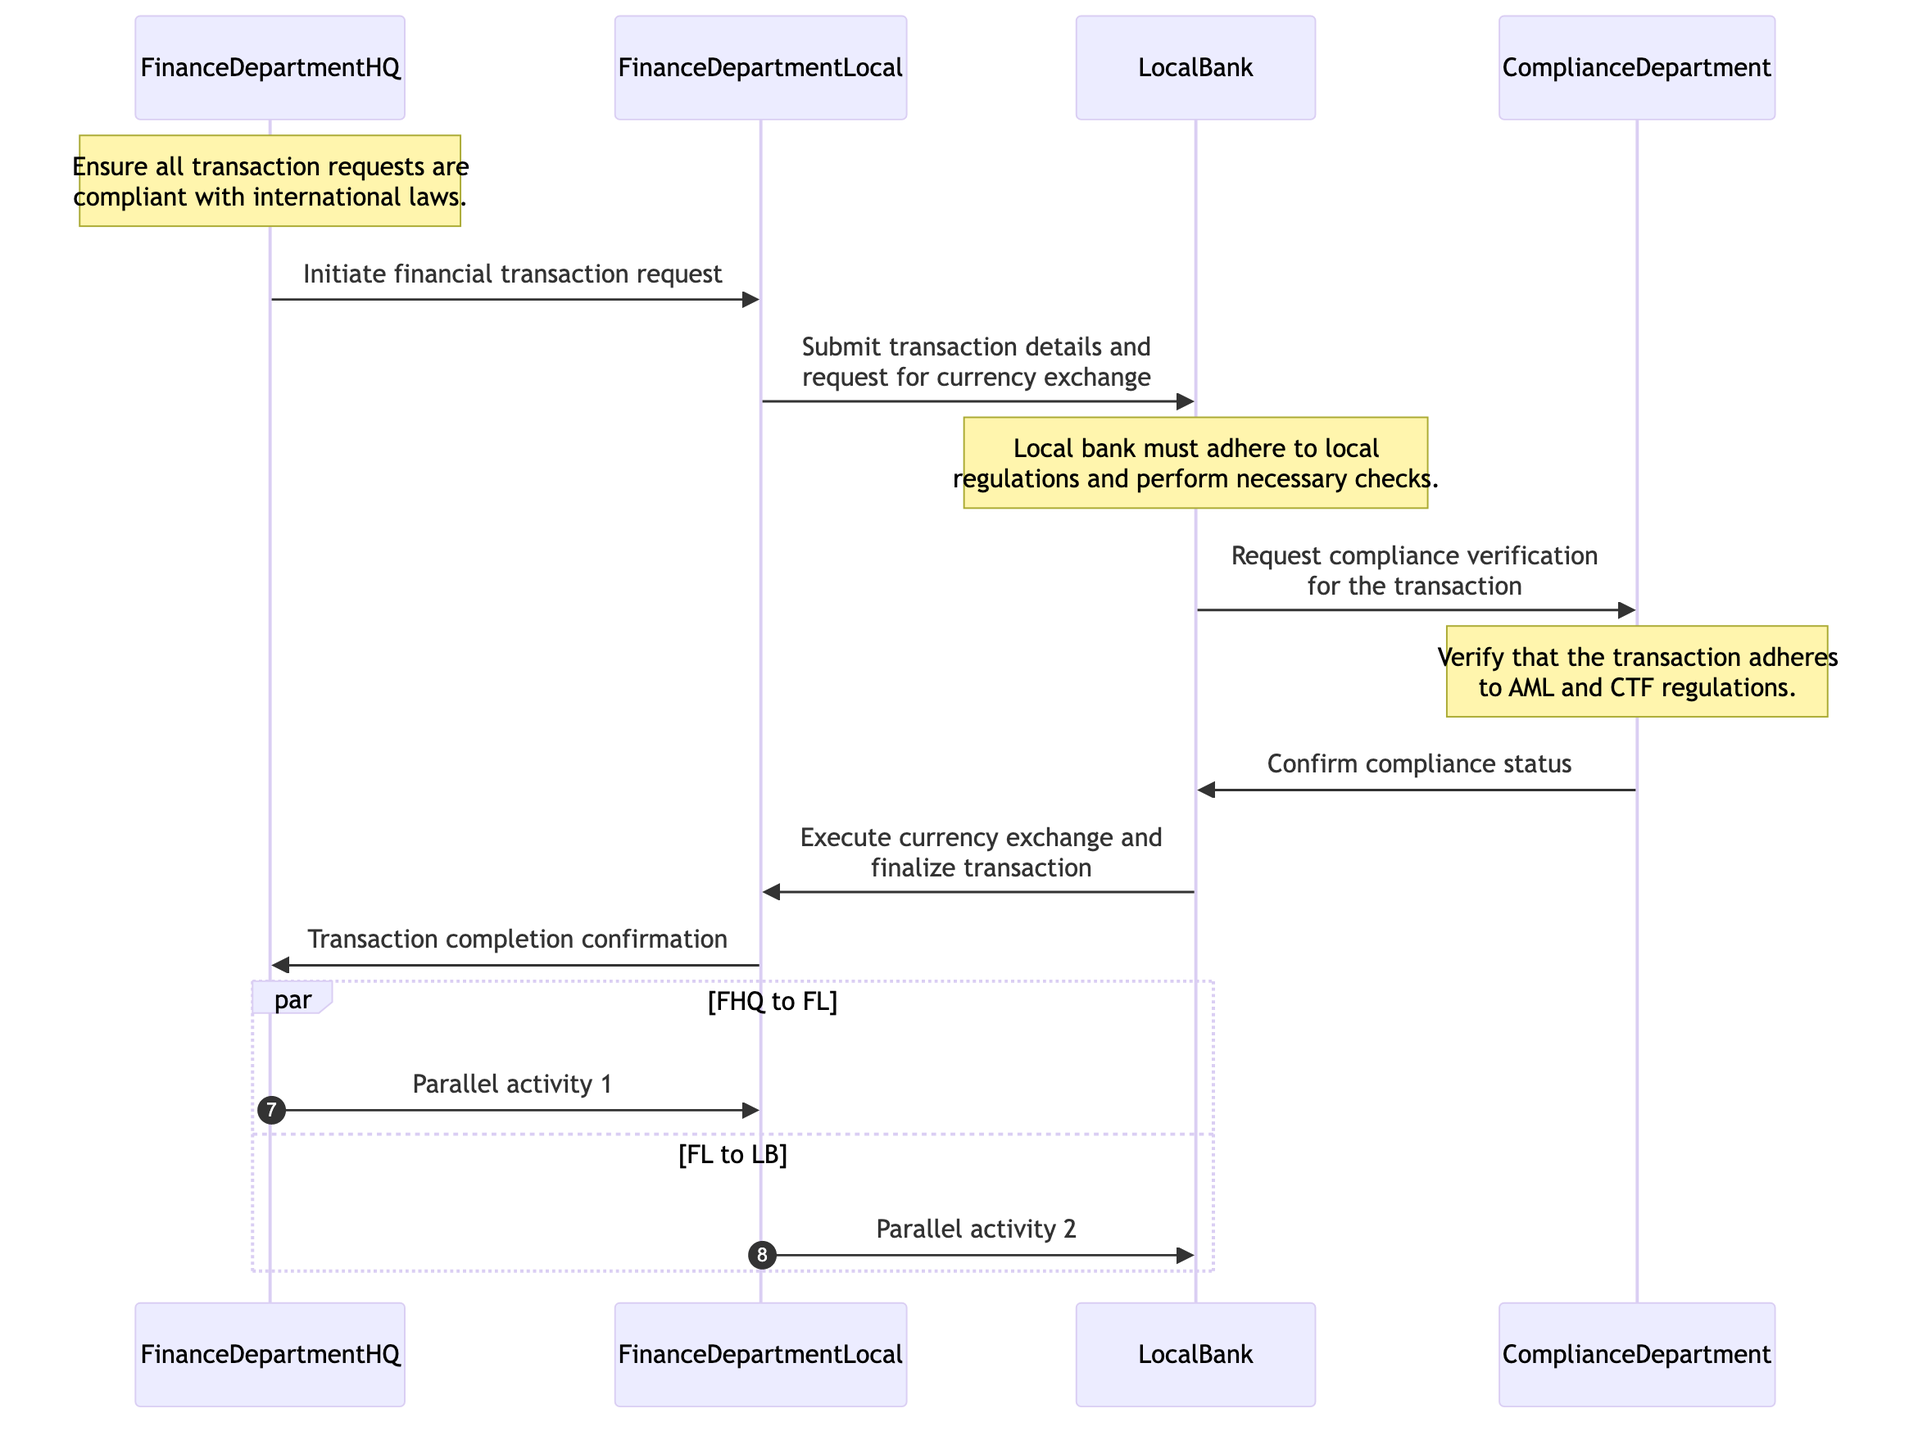What is the first message sent in the sequence? The sequence starts with a message from the Finance Department HQ to the Finance Department Local, which is "Initiate financial transaction request." This is the first action taken to begin the transaction process.
Answer: Initiate financial transaction request How many actors are involved in the diagram? The diagram includes four actors: Finance Department HQ, Finance Department Local, Local Bank, and Compliance Department. This is based on the list of actors provided in the diagram elements.
Answer: 4 Which department performs the compliance verification? The Compliance Department is responsible for verifying compliance as indicated in the message flow where the Local Bank requests compliance verification from this department.
Answer: Compliance Department What does the Local Bank need to adhere to? The Local Bank must adhere to local regulations and perform necessary checks, as noted in the comment above the Local Bank’s interactions in the diagram.
Answer: Local regulations What is the last message sent in the sequence? The last message in the sequence is from the Finance Department Local to the Finance Department HQ, confirming that the transaction has been completed.
Answer: Transaction completion confirmation How many steps are involved in the financial transaction request? The financial transaction request process consists of five distinct steps, evidenced by the messages exchanged between the actors before the transaction is finalized.
Answer: 5 What is confirmed in the response from the Compliance Department? The Compliance Department confirms "compliance status" to the Local Bank, which is essential for proceeding with the transaction.
Answer: Compliance status What type of regulations does the Compliance Department verify? The Compliance Department verifies that transactions adhere to Anti-Money Laundering (AML) and Counter-Terrorism Financing (CTF) regulations, as noted in the explanation section provided for this department.
Answer: AML and CTF regulations What actions take place in parallel as per the diagram? The diagram outlines two parallel activities: one where Finance Department HQ communicates with Finance Department Local and another where Finance Department Local interacts with the Local Bank simultaneously.
Answer: Parallel activity 1 and Parallel activity 2 